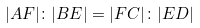Convert formula to latex. <formula><loc_0><loc_0><loc_500><loc_500>| A F | \colon | B E | = | F C | \colon | E D |</formula> 